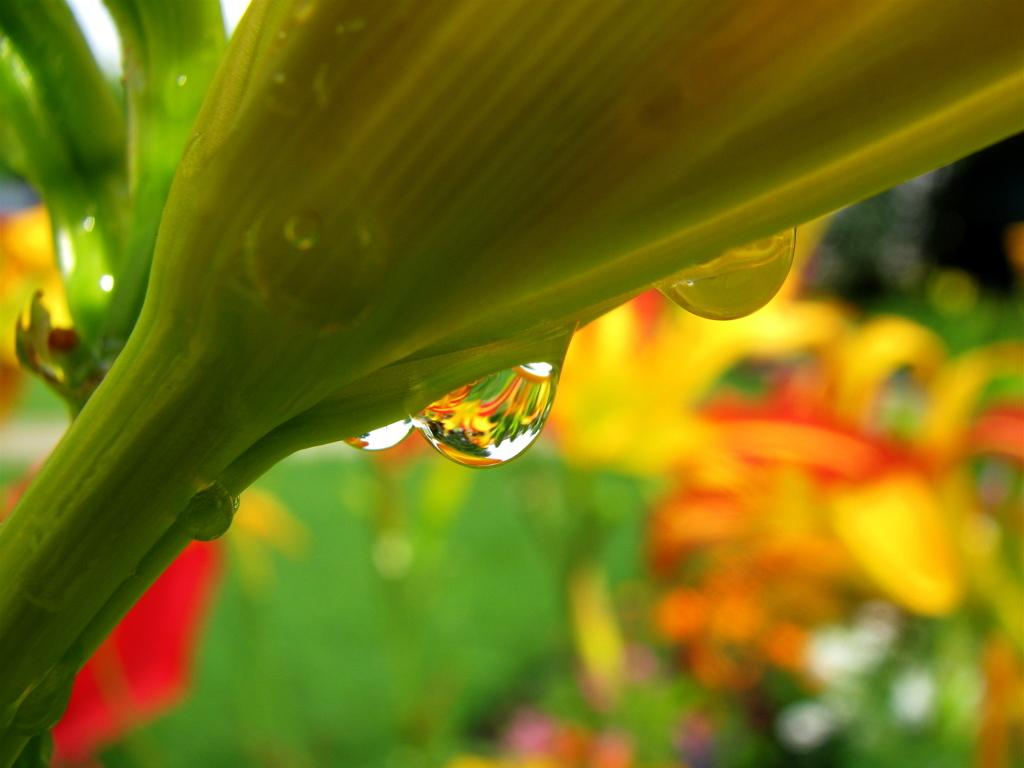What type of living organisms can be seen in the image? Plants can be seen in the image. What can be observed in the foreground of the image? There are water droplets in the front of the image. How would you describe the background of the image? The background of the image is blurred. How many eggs are being carried by the bee in the image? There is no bee or eggs present in the image. 